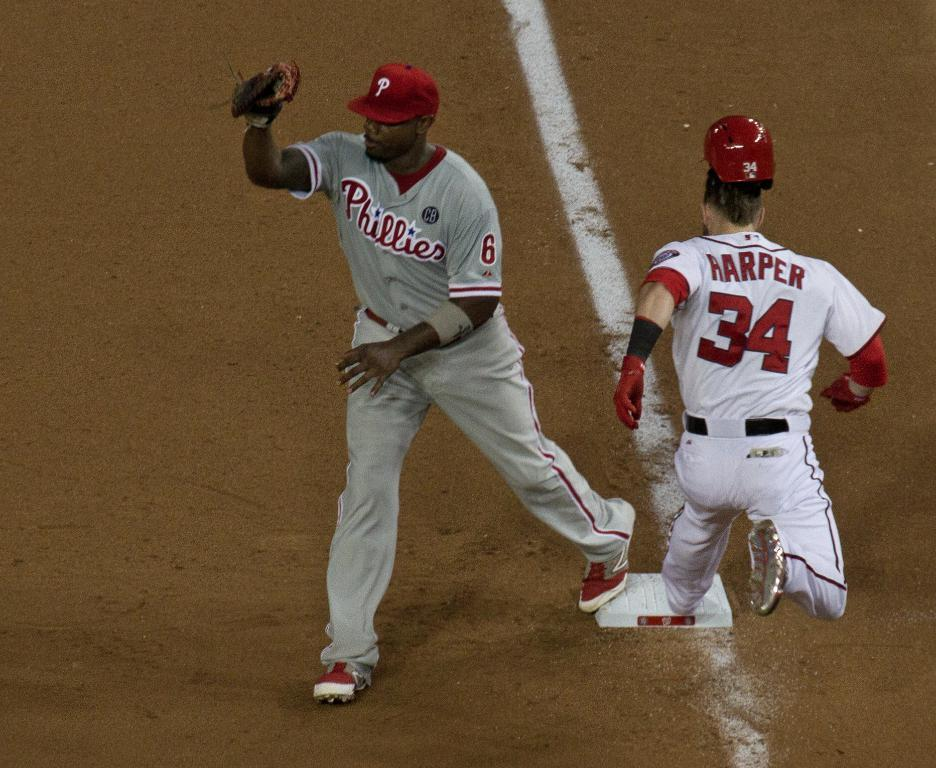<image>
Create a compact narrative representing the image presented. Stealing that first base from the Phillies baseman. 